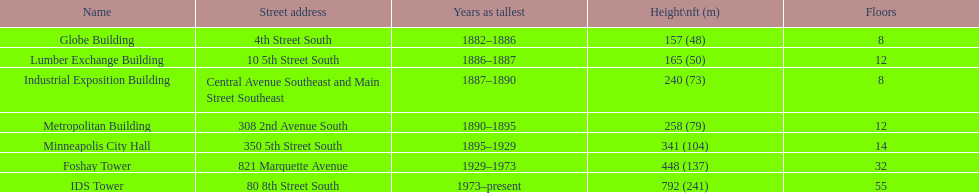What was the first building named as the tallest? Globe Building. 